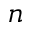Convert formula to latex. <formula><loc_0><loc_0><loc_500><loc_500>n</formula> 